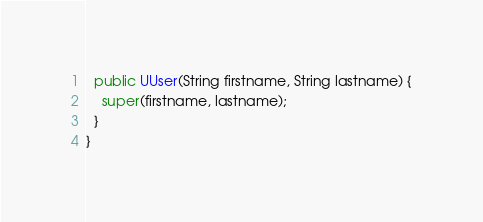<code> <loc_0><loc_0><loc_500><loc_500><_Java_>
  public UUser(String firstname, String lastname) {
    super(firstname, lastname);
  }
}
</code> 